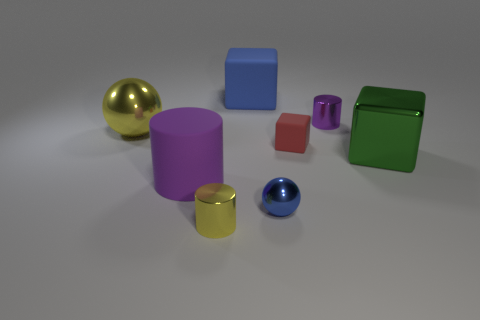There is a tiny object that is the same color as the big sphere; what is its shape?
Make the answer very short. Cylinder. There is a shiny object that is the same color as the large ball; what size is it?
Ensure brevity in your answer.  Small. Is the size of the metal cube the same as the blue shiny ball?
Your answer should be compact. No. Do the large blue object and the green object have the same shape?
Offer a terse response. Yes. The other rubber thing that is the same shape as the tiny red matte thing is what color?
Provide a short and direct response. Blue. Is the number of tiny yellow objects behind the big yellow shiny ball greater than the number of yellow objects to the right of the blue metallic thing?
Make the answer very short. No. How many other objects are the same shape as the red matte object?
Provide a succinct answer. 2. Are there any tiny red matte objects right of the small shiny thing that is to the left of the small blue thing?
Keep it short and to the point. Yes. What number of tiny yellow shiny cubes are there?
Your answer should be compact. 0. There is a large metal sphere; is it the same color as the small cylinder that is in front of the yellow shiny ball?
Your answer should be very brief. Yes. 